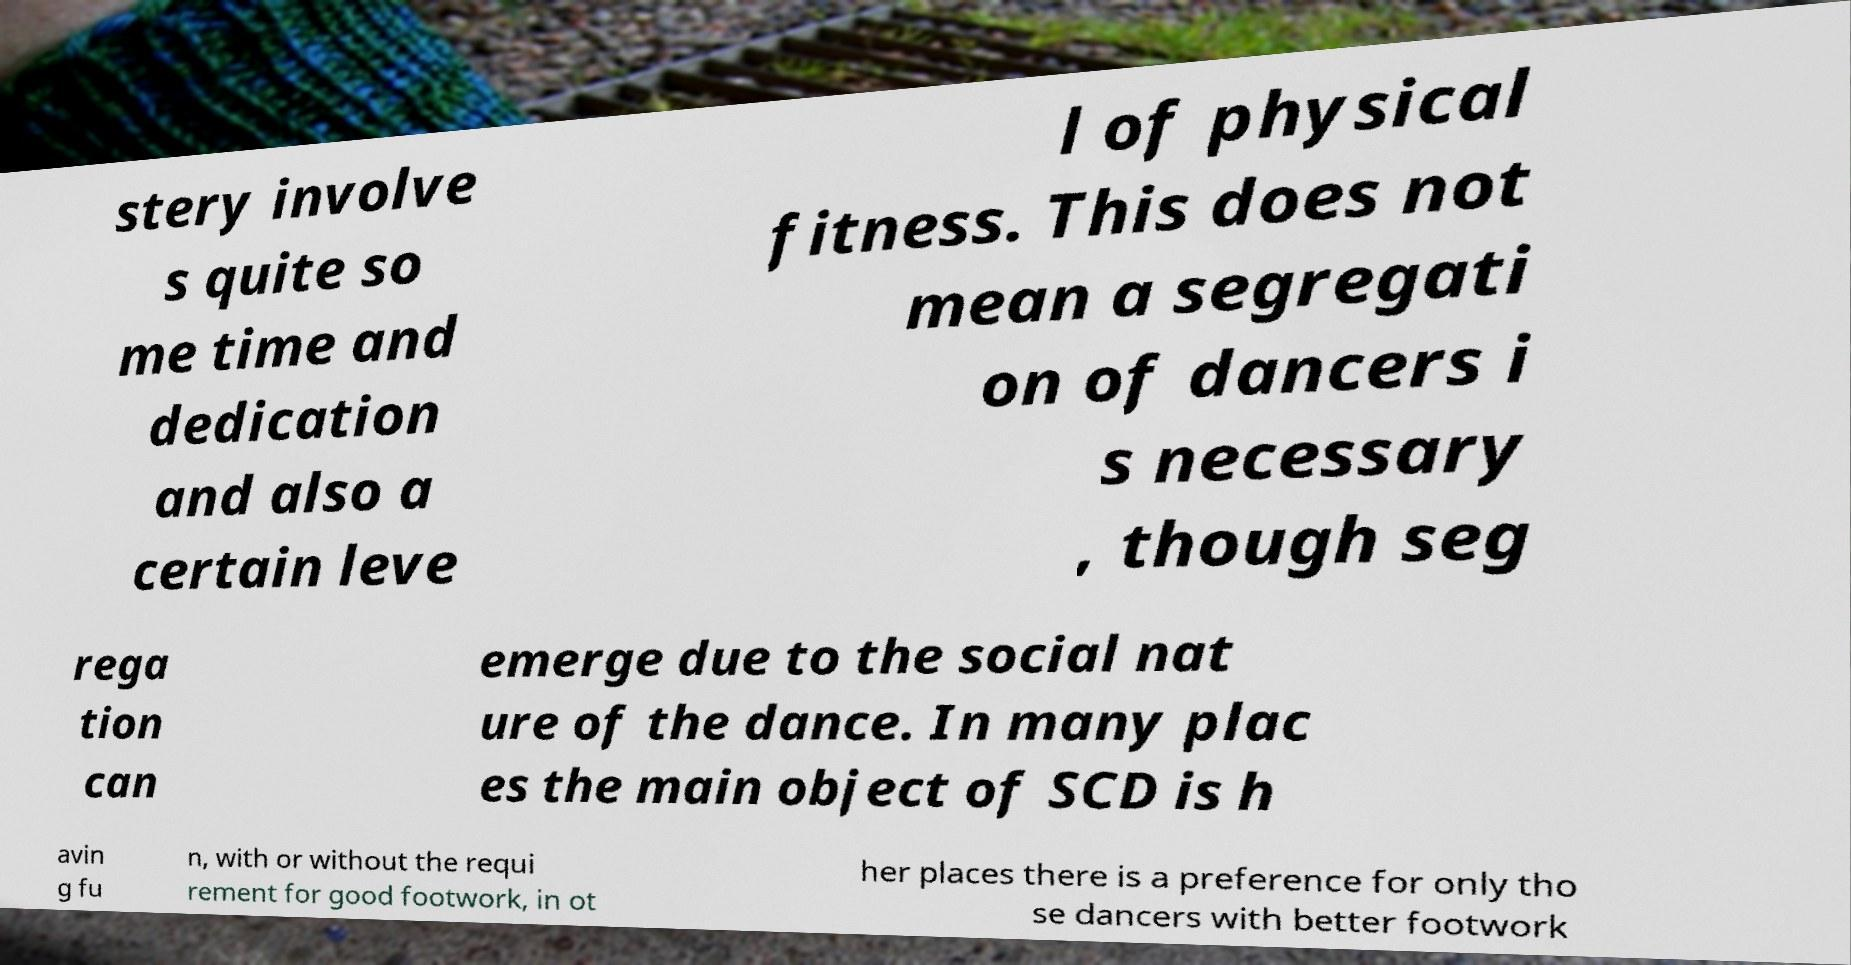What messages or text are displayed in this image? I need them in a readable, typed format. stery involve s quite so me time and dedication and also a certain leve l of physical fitness. This does not mean a segregati on of dancers i s necessary , though seg rega tion can emerge due to the social nat ure of the dance. In many plac es the main object of SCD is h avin g fu n, with or without the requi rement for good footwork, in ot her places there is a preference for only tho se dancers with better footwork 